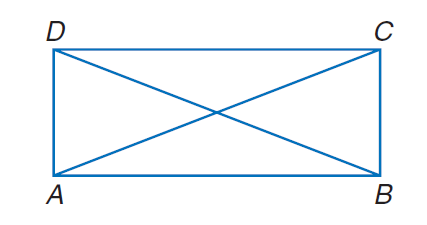Answer the mathemtical geometry problem and directly provide the correct option letter.
Question: A B C D is a rectangle. If A C = 30 - x and B D = 4 x - 60, find x.
Choices: A: 2 B: 9 C: 18 D: 36 C 